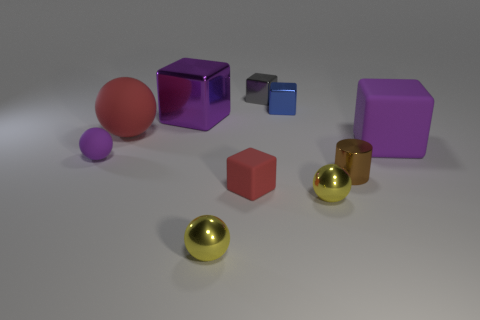Subtract 1 balls. How many balls are left? 3 Subtract all large purple matte cubes. How many cubes are left? 4 Subtract all red cubes. How many cubes are left? 4 Subtract all cyan balls. Subtract all yellow cylinders. How many balls are left? 4 Subtract all spheres. How many objects are left? 6 Add 1 big purple metal blocks. How many big purple metal blocks exist? 2 Subtract 2 yellow balls. How many objects are left? 8 Subtract all small purple balls. Subtract all small blue objects. How many objects are left? 8 Add 1 yellow shiny objects. How many yellow shiny objects are left? 3 